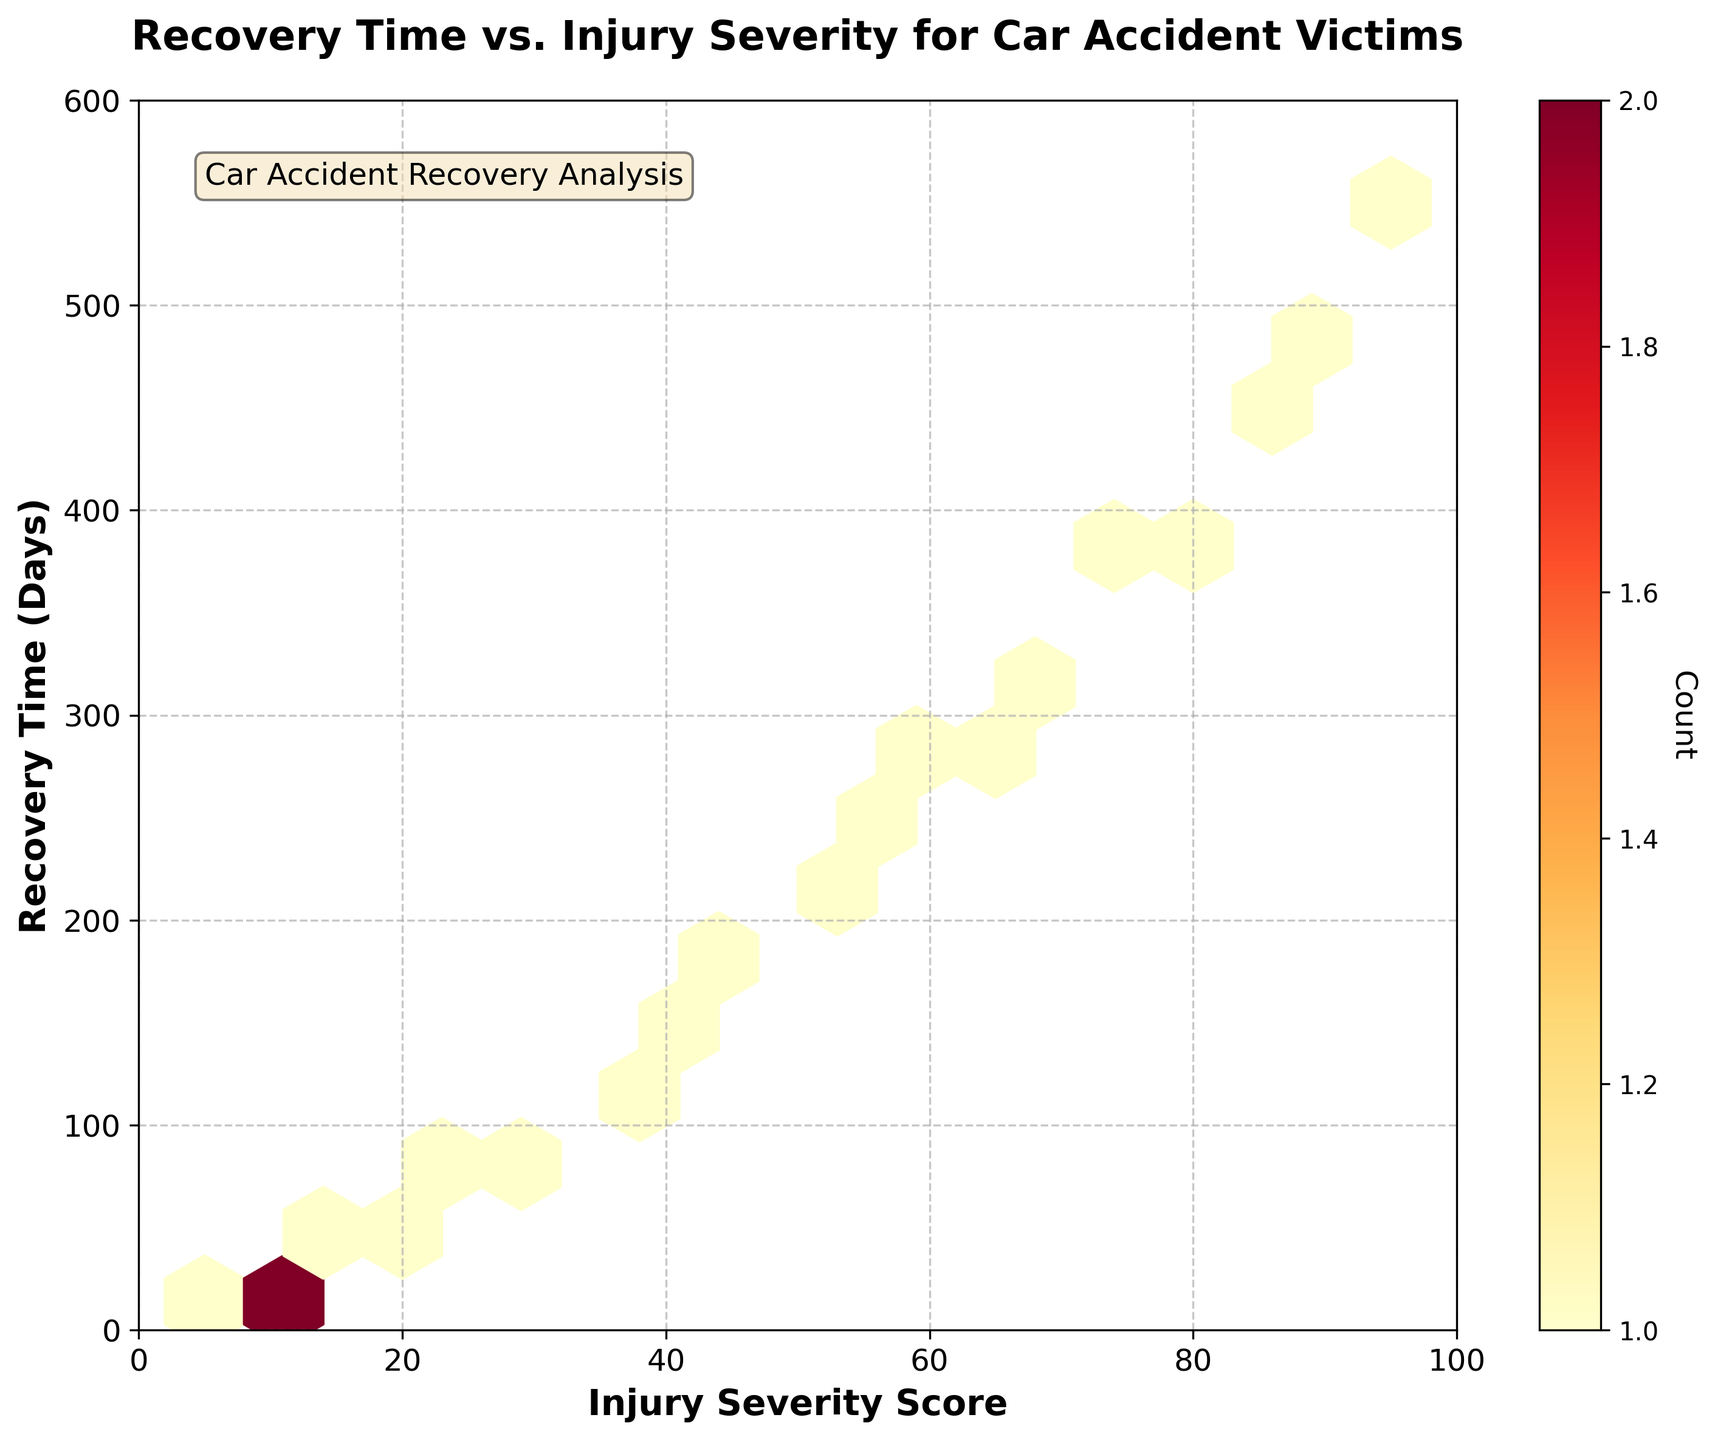What is the title of the plot? The title of the plot is written at the top of the figure.
Answer: Recovery Time vs. Injury Severity for Car Accident Victims What are the labels of the x-axis and y-axis? The x-axis and y-axis labels are shown along the horizontal and vertical axes respectively.
Answer: Injury Severity Score, Recovery Time (Days) What does the color of the hexagons represent? The color of the hexagons represents the count of data points in each hexbin. The color intensity increases with the count.
Answer: Count What is the range of the Injury Severity Score on the x-axis? The x-axis limits are indicated by the x-ticks and the axis itself.
Answer: 0 to 100 Where is the densest concentration of data points (hexagons) located? The densest concentration of data points can be identified by looking for the darkest (most intense) hexagons.
Answer: Between 40 and 60 Injury Severity Score, and between 200 and 300 recovery days Do higher Injury Severity Scores generally correspond to longer recovery times? You can observe the overall trend of the hexagons from left to right and bottom to top to see if there is an upward trend.
Answer: Yes Is there any recovery time less than 100 days with an Injury Severity Score above 70? Look at the hexagons in the lower right part of the plot, where the Injury Severity Score is above 70 and recovery times are less than 100 days.
Answer: No What can you infer about the relationship between Injury Severity Score and Recovery Time? To infer the relationship, observe the general pattern of the hexagons across the plot. The positive slope implies that as one variable increases, so does the other.
Answer: Positive correlation How does the Recovery Time compare between Injury Severity Scores of 20 and 60? Compare the vertical positions of hexagons that start with Injury Severity Scores around 20 and 60.
Answer: Recovery Time for a Score of 60 is higher than for 20 